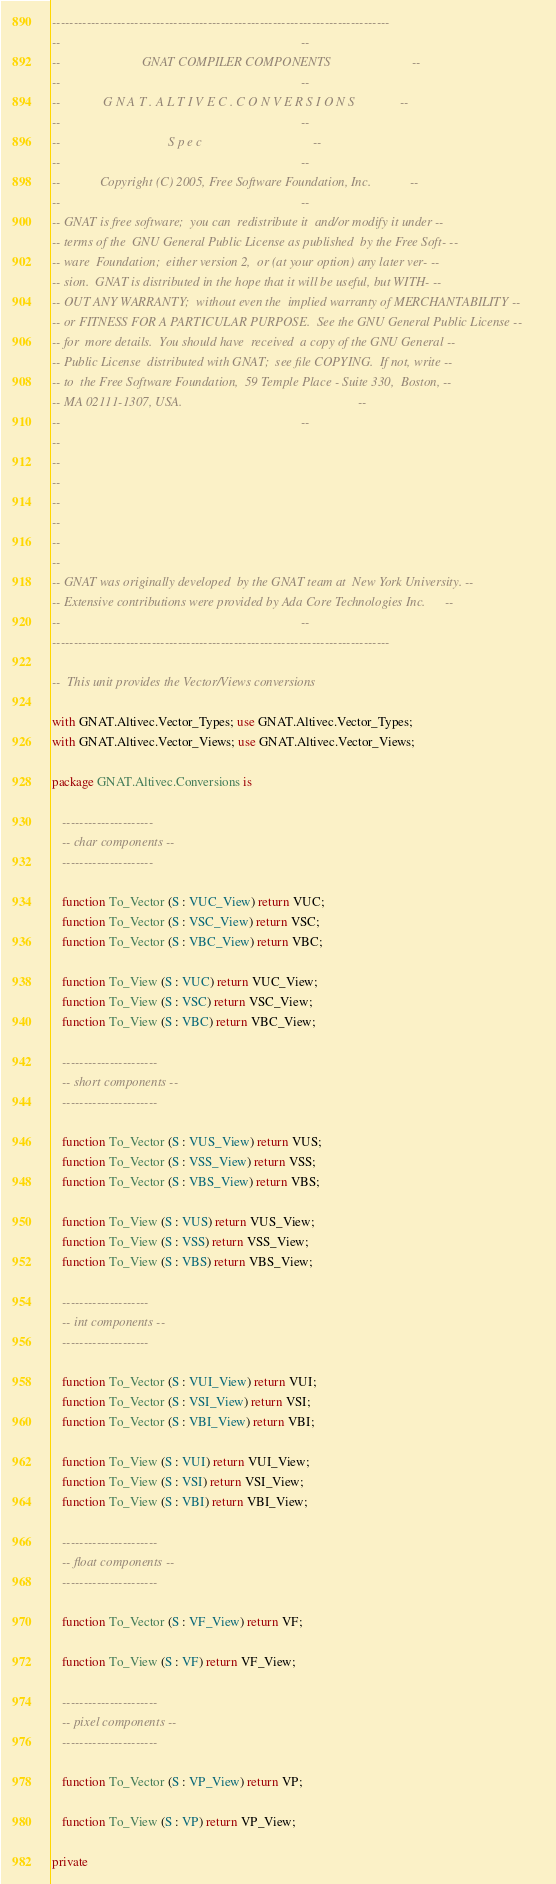Convert code to text. <code><loc_0><loc_0><loc_500><loc_500><_Ada_>------------------------------------------------------------------------------
--                                                                          --
--                         GNAT COMPILER COMPONENTS                         --
--                                                                          --
--             G N A T . A L T I V E C . C O N V E R S I O N S              --
--                                                                          --
--                                 S p e c                                  --
--                                                                          --
--            Copyright (C) 2005, Free Software Foundation, Inc.            --
--                                                                          --
-- GNAT is free software;  you can  redistribute it  and/or modify it under --
-- terms of the  GNU General Public License as published  by the Free Soft- --
-- ware  Foundation;  either version 2,  or (at your option) any later ver- --
-- sion.  GNAT is distributed in the hope that it will be useful, but WITH- --
-- OUT ANY WARRANTY;  without even the  implied warranty of MERCHANTABILITY --
-- or FITNESS FOR A PARTICULAR PURPOSE.  See the GNU General Public License --
-- for  more details.  You should have  received  a copy of the GNU General --
-- Public License  distributed with GNAT;  see file COPYING.  If not, write --
-- to  the Free Software Foundation,  59 Temple Place - Suite 330,  Boston, --
-- MA 02111-1307, USA.                                                      --
--                                                                          --
--
--
--
--
--
--
--
-- GNAT was originally developed  by the GNAT team at  New York University. --
-- Extensive contributions were provided by Ada Core Technologies Inc.      --
--                                                                          --
------------------------------------------------------------------------------

--  This unit provides the Vector/Views conversions

with GNAT.Altivec.Vector_Types; use GNAT.Altivec.Vector_Types;
with GNAT.Altivec.Vector_Views; use GNAT.Altivec.Vector_Views;

package GNAT.Altivec.Conversions is

   ---------------------
   -- char components --
   ---------------------

   function To_Vector (S : VUC_View) return VUC;
   function To_Vector (S : VSC_View) return VSC;
   function To_Vector (S : VBC_View) return VBC;

   function To_View (S : VUC) return VUC_View;
   function To_View (S : VSC) return VSC_View;
   function To_View (S : VBC) return VBC_View;

   ----------------------
   -- short components --
   ----------------------

   function To_Vector (S : VUS_View) return VUS;
   function To_Vector (S : VSS_View) return VSS;
   function To_Vector (S : VBS_View) return VBS;

   function To_View (S : VUS) return VUS_View;
   function To_View (S : VSS) return VSS_View;
   function To_View (S : VBS) return VBS_View;

   --------------------
   -- int components --
   --------------------

   function To_Vector (S : VUI_View) return VUI;
   function To_Vector (S : VSI_View) return VSI;
   function To_Vector (S : VBI_View) return VBI;

   function To_View (S : VUI) return VUI_View;
   function To_View (S : VSI) return VSI_View;
   function To_View (S : VBI) return VBI_View;

   ----------------------
   -- float components --
   ----------------------

   function To_Vector (S : VF_View) return VF;

   function To_View (S : VF) return VF_View;

   ----------------------
   -- pixel components --
   ----------------------

   function To_Vector (S : VP_View) return VP;

   function To_View (S : VP) return VP_View;

private
</code> 